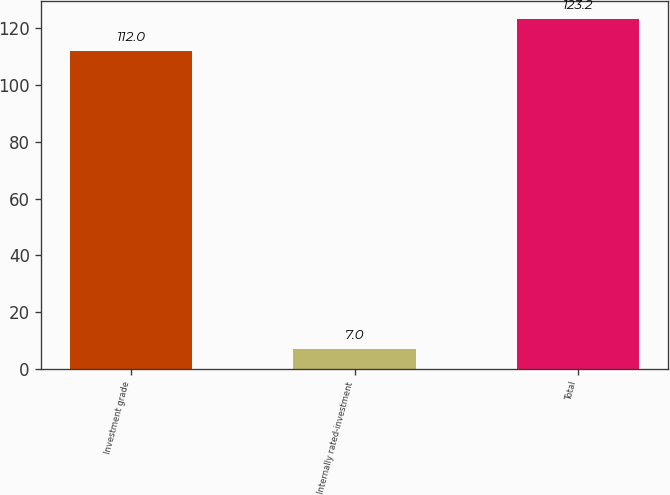<chart> <loc_0><loc_0><loc_500><loc_500><bar_chart><fcel>Investment grade<fcel>Internally rated-investment<fcel>Total<nl><fcel>112<fcel>7<fcel>123.2<nl></chart> 